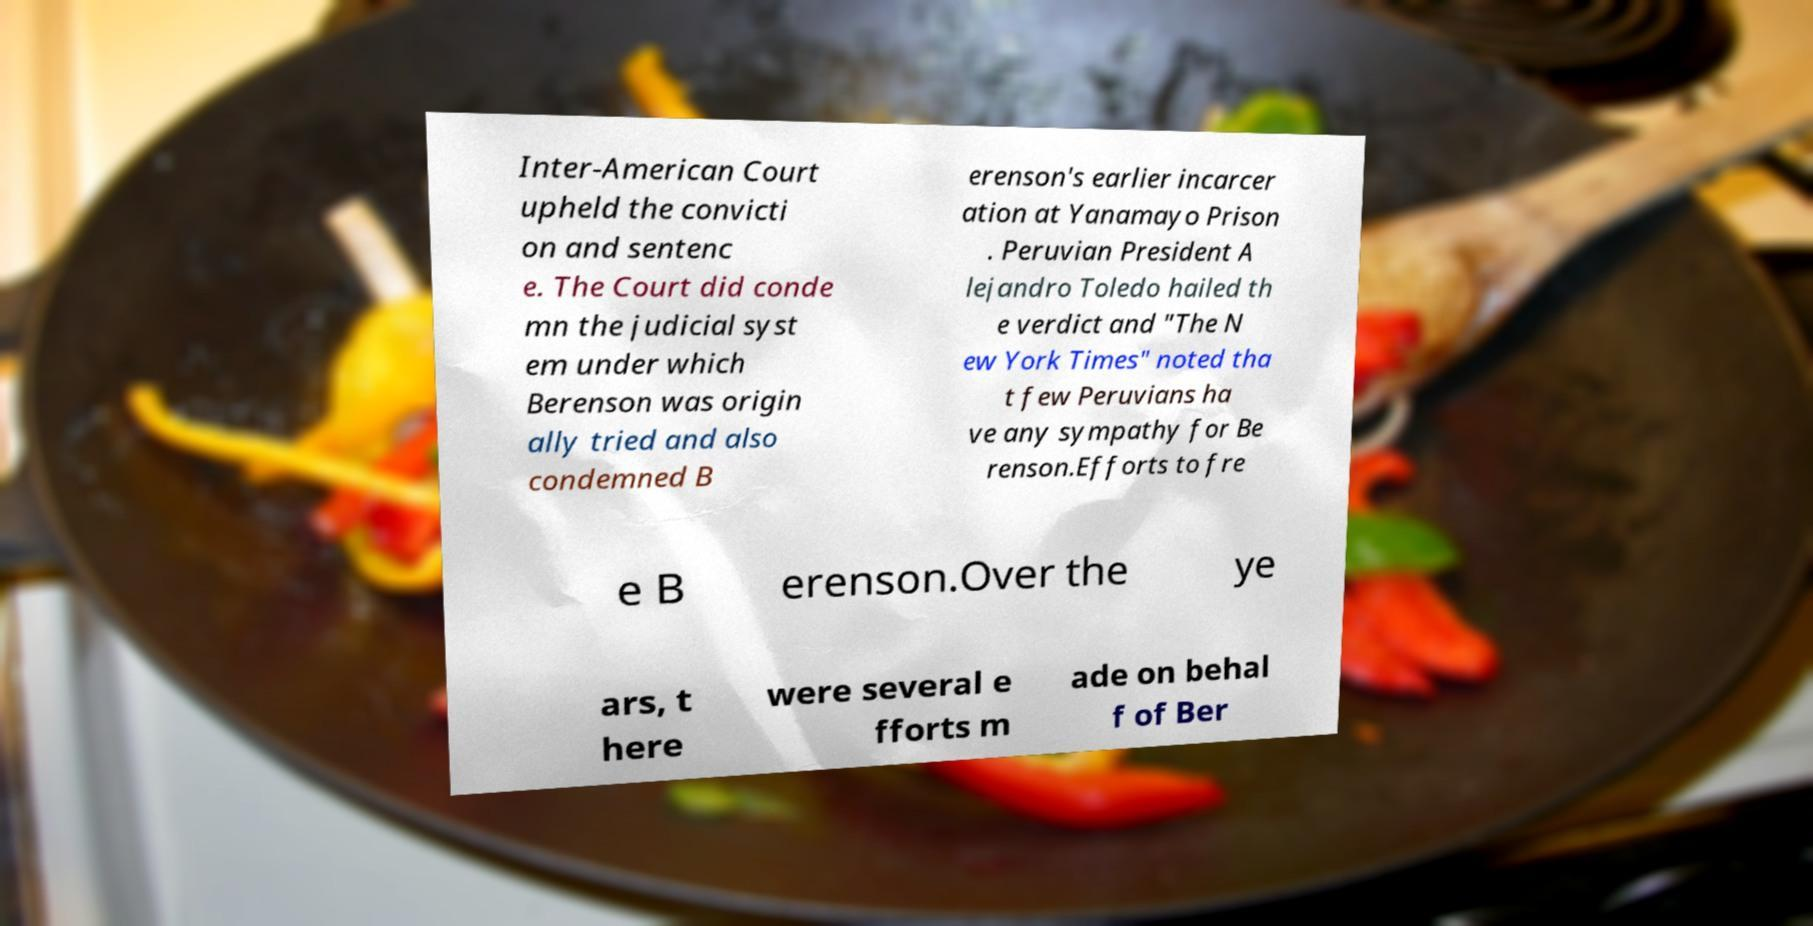What messages or text are displayed in this image? I need them in a readable, typed format. Inter-American Court upheld the convicti on and sentenc e. The Court did conde mn the judicial syst em under which Berenson was origin ally tried and also condemned B erenson's earlier incarcer ation at Yanamayo Prison . Peruvian President A lejandro Toledo hailed th e verdict and "The N ew York Times" noted tha t few Peruvians ha ve any sympathy for Be renson.Efforts to fre e B erenson.Over the ye ars, t here were several e fforts m ade on behal f of Ber 